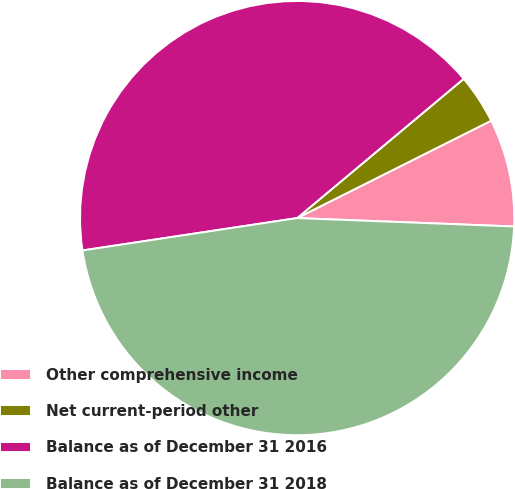Convert chart. <chart><loc_0><loc_0><loc_500><loc_500><pie_chart><fcel>Other comprehensive income<fcel>Net current-period other<fcel>Balance as of December 31 2016<fcel>Balance as of December 31 2018<nl><fcel>8.02%<fcel>3.68%<fcel>41.3%<fcel>47.0%<nl></chart> 